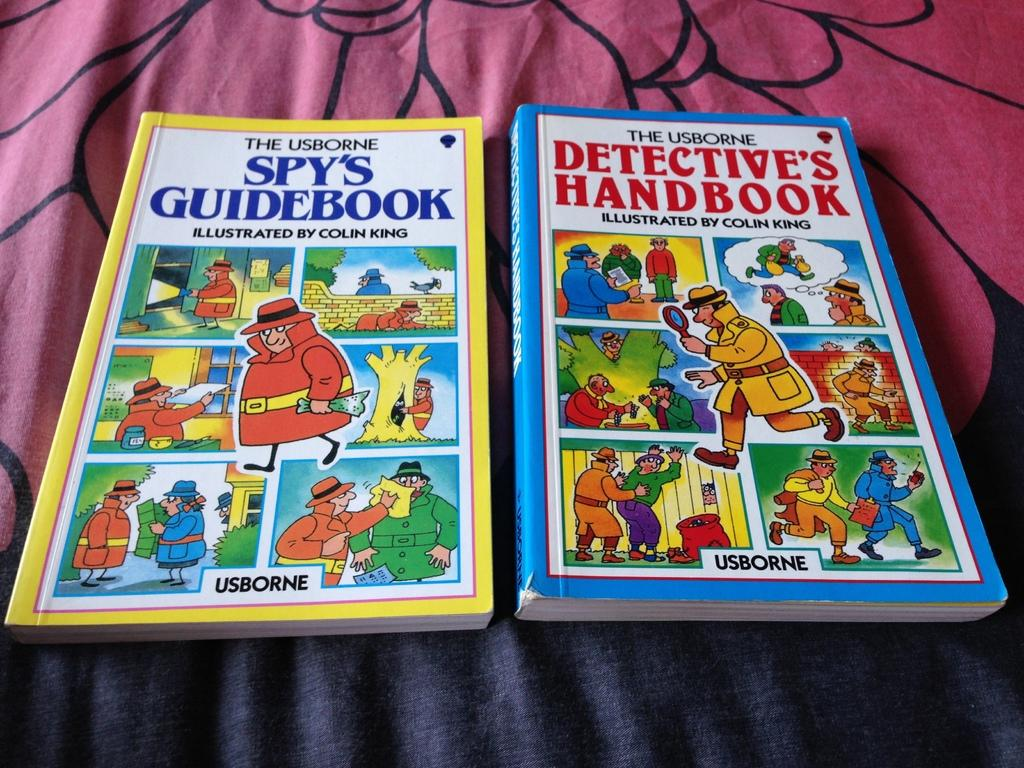<image>
Share a concise interpretation of the image provided. Colin King is the illustrator of both Osborne books. 